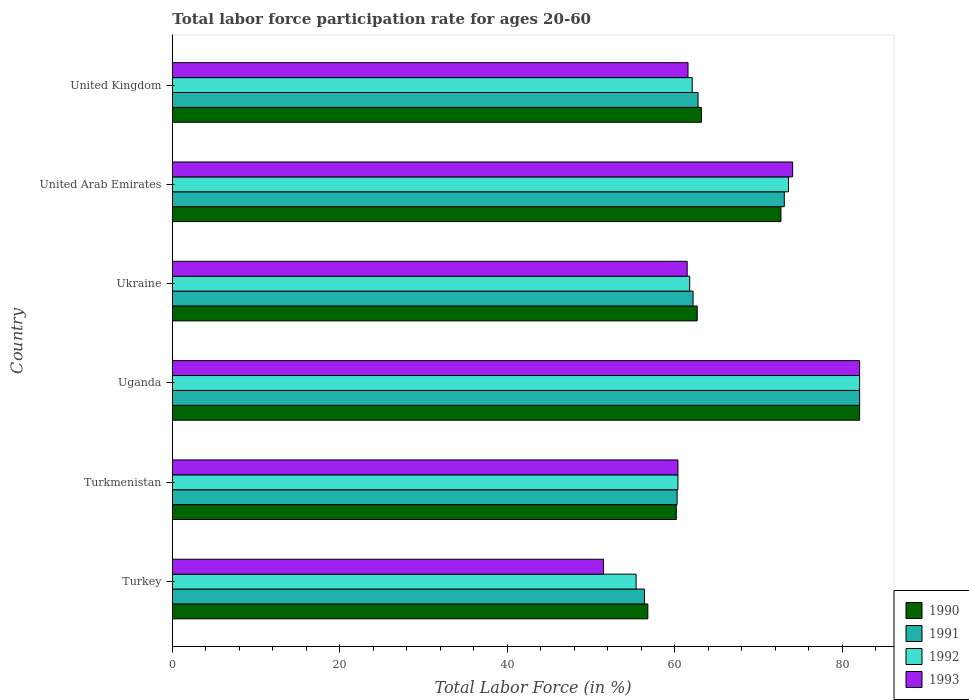How many groups of bars are there?
Give a very brief answer. 6. How many bars are there on the 6th tick from the top?
Keep it short and to the point. 4. How many bars are there on the 5th tick from the bottom?
Your response must be concise. 4. In how many cases, is the number of bars for a given country not equal to the number of legend labels?
Keep it short and to the point. 0. What is the labor force participation rate in 1992 in United Kingdom?
Ensure brevity in your answer.  62.1. Across all countries, what is the maximum labor force participation rate in 1990?
Ensure brevity in your answer.  82.1. Across all countries, what is the minimum labor force participation rate in 1992?
Make the answer very short. 55.4. In which country was the labor force participation rate in 1991 maximum?
Offer a very short reply. Uganda. In which country was the labor force participation rate in 1992 minimum?
Keep it short and to the point. Turkey. What is the total labor force participation rate in 1992 in the graph?
Offer a terse response. 395.4. What is the difference between the labor force participation rate in 1991 in Turkey and that in United Arab Emirates?
Offer a very short reply. -16.7. What is the difference between the labor force participation rate in 1992 in Turkmenistan and the labor force participation rate in 1990 in United Arab Emirates?
Ensure brevity in your answer.  -12.3. What is the average labor force participation rate in 1990 per country?
Provide a succinct answer. 66.28. What is the difference between the labor force participation rate in 1990 and labor force participation rate in 1991 in Turkmenistan?
Your answer should be compact. -0.1. In how many countries, is the labor force participation rate in 1991 greater than 60 %?
Ensure brevity in your answer.  5. What is the ratio of the labor force participation rate in 1991 in Turkmenistan to that in Uganda?
Provide a succinct answer. 0.73. Is the labor force participation rate in 1991 in United Arab Emirates less than that in United Kingdom?
Make the answer very short. No. Is the difference between the labor force participation rate in 1990 in Uganda and United Kingdom greater than the difference between the labor force participation rate in 1991 in Uganda and United Kingdom?
Your response must be concise. No. What is the difference between the highest and the lowest labor force participation rate in 1992?
Ensure brevity in your answer.  26.7. In how many countries, is the labor force participation rate in 1990 greater than the average labor force participation rate in 1990 taken over all countries?
Keep it short and to the point. 2. What does the 1st bar from the top in Ukraine represents?
Ensure brevity in your answer.  1993. Are all the bars in the graph horizontal?
Keep it short and to the point. Yes. How many countries are there in the graph?
Keep it short and to the point. 6. What is the difference between two consecutive major ticks on the X-axis?
Make the answer very short. 20. Are the values on the major ticks of X-axis written in scientific E-notation?
Give a very brief answer. No. Does the graph contain any zero values?
Your answer should be very brief. No. Does the graph contain grids?
Offer a very short reply. No. Where does the legend appear in the graph?
Offer a very short reply. Bottom right. How many legend labels are there?
Make the answer very short. 4. What is the title of the graph?
Your answer should be compact. Total labor force participation rate for ages 20-60. Does "1966" appear as one of the legend labels in the graph?
Provide a succinct answer. No. What is the label or title of the X-axis?
Provide a short and direct response. Total Labor Force (in %). What is the label or title of the Y-axis?
Provide a succinct answer. Country. What is the Total Labor Force (in %) in 1990 in Turkey?
Give a very brief answer. 56.8. What is the Total Labor Force (in %) of 1991 in Turkey?
Keep it short and to the point. 56.4. What is the Total Labor Force (in %) of 1992 in Turkey?
Offer a terse response. 55.4. What is the Total Labor Force (in %) in 1993 in Turkey?
Offer a very short reply. 51.5. What is the Total Labor Force (in %) in 1990 in Turkmenistan?
Ensure brevity in your answer.  60.2. What is the Total Labor Force (in %) of 1991 in Turkmenistan?
Your answer should be compact. 60.3. What is the Total Labor Force (in %) in 1992 in Turkmenistan?
Ensure brevity in your answer.  60.4. What is the Total Labor Force (in %) in 1993 in Turkmenistan?
Give a very brief answer. 60.4. What is the Total Labor Force (in %) of 1990 in Uganda?
Provide a succinct answer. 82.1. What is the Total Labor Force (in %) of 1991 in Uganda?
Provide a succinct answer. 82.1. What is the Total Labor Force (in %) in 1992 in Uganda?
Ensure brevity in your answer.  82.1. What is the Total Labor Force (in %) of 1993 in Uganda?
Provide a short and direct response. 82.1. What is the Total Labor Force (in %) in 1990 in Ukraine?
Your answer should be very brief. 62.7. What is the Total Labor Force (in %) in 1991 in Ukraine?
Your answer should be compact. 62.2. What is the Total Labor Force (in %) of 1992 in Ukraine?
Ensure brevity in your answer.  61.8. What is the Total Labor Force (in %) of 1993 in Ukraine?
Make the answer very short. 61.5. What is the Total Labor Force (in %) in 1990 in United Arab Emirates?
Make the answer very short. 72.7. What is the Total Labor Force (in %) of 1991 in United Arab Emirates?
Make the answer very short. 73.1. What is the Total Labor Force (in %) in 1992 in United Arab Emirates?
Give a very brief answer. 73.6. What is the Total Labor Force (in %) of 1993 in United Arab Emirates?
Keep it short and to the point. 74.1. What is the Total Labor Force (in %) in 1990 in United Kingdom?
Give a very brief answer. 63.2. What is the Total Labor Force (in %) in 1991 in United Kingdom?
Ensure brevity in your answer.  62.8. What is the Total Labor Force (in %) of 1992 in United Kingdom?
Keep it short and to the point. 62.1. What is the Total Labor Force (in %) of 1993 in United Kingdom?
Keep it short and to the point. 61.6. Across all countries, what is the maximum Total Labor Force (in %) in 1990?
Your response must be concise. 82.1. Across all countries, what is the maximum Total Labor Force (in %) in 1991?
Keep it short and to the point. 82.1. Across all countries, what is the maximum Total Labor Force (in %) in 1992?
Provide a short and direct response. 82.1. Across all countries, what is the maximum Total Labor Force (in %) in 1993?
Keep it short and to the point. 82.1. Across all countries, what is the minimum Total Labor Force (in %) in 1990?
Provide a succinct answer. 56.8. Across all countries, what is the minimum Total Labor Force (in %) in 1991?
Keep it short and to the point. 56.4. Across all countries, what is the minimum Total Labor Force (in %) of 1992?
Make the answer very short. 55.4. Across all countries, what is the minimum Total Labor Force (in %) in 1993?
Your answer should be compact. 51.5. What is the total Total Labor Force (in %) in 1990 in the graph?
Keep it short and to the point. 397.7. What is the total Total Labor Force (in %) in 1991 in the graph?
Ensure brevity in your answer.  396.9. What is the total Total Labor Force (in %) in 1992 in the graph?
Offer a terse response. 395.4. What is the total Total Labor Force (in %) in 1993 in the graph?
Provide a short and direct response. 391.2. What is the difference between the Total Labor Force (in %) in 1990 in Turkey and that in Turkmenistan?
Your answer should be compact. -3.4. What is the difference between the Total Labor Force (in %) of 1991 in Turkey and that in Turkmenistan?
Provide a succinct answer. -3.9. What is the difference between the Total Labor Force (in %) in 1992 in Turkey and that in Turkmenistan?
Provide a succinct answer. -5. What is the difference between the Total Labor Force (in %) of 1993 in Turkey and that in Turkmenistan?
Provide a succinct answer. -8.9. What is the difference between the Total Labor Force (in %) in 1990 in Turkey and that in Uganda?
Keep it short and to the point. -25.3. What is the difference between the Total Labor Force (in %) in 1991 in Turkey and that in Uganda?
Make the answer very short. -25.7. What is the difference between the Total Labor Force (in %) of 1992 in Turkey and that in Uganda?
Ensure brevity in your answer.  -26.7. What is the difference between the Total Labor Force (in %) of 1993 in Turkey and that in Uganda?
Offer a very short reply. -30.6. What is the difference between the Total Labor Force (in %) in 1991 in Turkey and that in Ukraine?
Give a very brief answer. -5.8. What is the difference between the Total Labor Force (in %) in 1992 in Turkey and that in Ukraine?
Keep it short and to the point. -6.4. What is the difference between the Total Labor Force (in %) in 1990 in Turkey and that in United Arab Emirates?
Give a very brief answer. -15.9. What is the difference between the Total Labor Force (in %) in 1991 in Turkey and that in United Arab Emirates?
Keep it short and to the point. -16.7. What is the difference between the Total Labor Force (in %) of 1992 in Turkey and that in United Arab Emirates?
Ensure brevity in your answer.  -18.2. What is the difference between the Total Labor Force (in %) of 1993 in Turkey and that in United Arab Emirates?
Provide a succinct answer. -22.6. What is the difference between the Total Labor Force (in %) of 1990 in Turkey and that in United Kingdom?
Keep it short and to the point. -6.4. What is the difference between the Total Labor Force (in %) of 1991 in Turkey and that in United Kingdom?
Provide a short and direct response. -6.4. What is the difference between the Total Labor Force (in %) in 1992 in Turkey and that in United Kingdom?
Offer a terse response. -6.7. What is the difference between the Total Labor Force (in %) in 1993 in Turkey and that in United Kingdom?
Give a very brief answer. -10.1. What is the difference between the Total Labor Force (in %) in 1990 in Turkmenistan and that in Uganda?
Offer a terse response. -21.9. What is the difference between the Total Labor Force (in %) in 1991 in Turkmenistan and that in Uganda?
Offer a very short reply. -21.8. What is the difference between the Total Labor Force (in %) of 1992 in Turkmenistan and that in Uganda?
Offer a terse response. -21.7. What is the difference between the Total Labor Force (in %) in 1993 in Turkmenistan and that in Uganda?
Offer a very short reply. -21.7. What is the difference between the Total Labor Force (in %) in 1990 in Turkmenistan and that in Ukraine?
Provide a short and direct response. -2.5. What is the difference between the Total Labor Force (in %) of 1992 in Turkmenistan and that in Ukraine?
Your response must be concise. -1.4. What is the difference between the Total Labor Force (in %) in 1993 in Turkmenistan and that in Ukraine?
Your response must be concise. -1.1. What is the difference between the Total Labor Force (in %) of 1991 in Turkmenistan and that in United Arab Emirates?
Your answer should be very brief. -12.8. What is the difference between the Total Labor Force (in %) of 1992 in Turkmenistan and that in United Arab Emirates?
Ensure brevity in your answer.  -13.2. What is the difference between the Total Labor Force (in %) in 1993 in Turkmenistan and that in United Arab Emirates?
Offer a terse response. -13.7. What is the difference between the Total Labor Force (in %) in 1992 in Turkmenistan and that in United Kingdom?
Your answer should be compact. -1.7. What is the difference between the Total Labor Force (in %) of 1990 in Uganda and that in Ukraine?
Your answer should be very brief. 19.4. What is the difference between the Total Labor Force (in %) of 1991 in Uganda and that in Ukraine?
Provide a succinct answer. 19.9. What is the difference between the Total Labor Force (in %) of 1992 in Uganda and that in Ukraine?
Ensure brevity in your answer.  20.3. What is the difference between the Total Labor Force (in %) of 1993 in Uganda and that in Ukraine?
Your answer should be compact. 20.6. What is the difference between the Total Labor Force (in %) of 1990 in Uganda and that in United Arab Emirates?
Provide a succinct answer. 9.4. What is the difference between the Total Labor Force (in %) of 1990 in Uganda and that in United Kingdom?
Make the answer very short. 18.9. What is the difference between the Total Labor Force (in %) in 1991 in Uganda and that in United Kingdom?
Keep it short and to the point. 19.3. What is the difference between the Total Labor Force (in %) in 1990 in Ukraine and that in United Arab Emirates?
Your answer should be very brief. -10. What is the difference between the Total Labor Force (in %) of 1993 in Ukraine and that in United Arab Emirates?
Offer a very short reply. -12.6. What is the difference between the Total Labor Force (in %) of 1990 in Ukraine and that in United Kingdom?
Make the answer very short. -0.5. What is the difference between the Total Labor Force (in %) in 1991 in Ukraine and that in United Kingdom?
Provide a succinct answer. -0.6. What is the difference between the Total Labor Force (in %) in 1990 in United Arab Emirates and that in United Kingdom?
Keep it short and to the point. 9.5. What is the difference between the Total Labor Force (in %) of 1991 in United Arab Emirates and that in United Kingdom?
Provide a short and direct response. 10.3. What is the difference between the Total Labor Force (in %) of 1993 in United Arab Emirates and that in United Kingdom?
Provide a short and direct response. 12.5. What is the difference between the Total Labor Force (in %) of 1990 in Turkey and the Total Labor Force (in %) of 1991 in Turkmenistan?
Your answer should be very brief. -3.5. What is the difference between the Total Labor Force (in %) of 1990 in Turkey and the Total Labor Force (in %) of 1992 in Turkmenistan?
Provide a short and direct response. -3.6. What is the difference between the Total Labor Force (in %) of 1990 in Turkey and the Total Labor Force (in %) of 1993 in Turkmenistan?
Keep it short and to the point. -3.6. What is the difference between the Total Labor Force (in %) in 1990 in Turkey and the Total Labor Force (in %) in 1991 in Uganda?
Your answer should be very brief. -25.3. What is the difference between the Total Labor Force (in %) in 1990 in Turkey and the Total Labor Force (in %) in 1992 in Uganda?
Offer a very short reply. -25.3. What is the difference between the Total Labor Force (in %) of 1990 in Turkey and the Total Labor Force (in %) of 1993 in Uganda?
Give a very brief answer. -25.3. What is the difference between the Total Labor Force (in %) in 1991 in Turkey and the Total Labor Force (in %) in 1992 in Uganda?
Offer a terse response. -25.7. What is the difference between the Total Labor Force (in %) in 1991 in Turkey and the Total Labor Force (in %) in 1993 in Uganda?
Your response must be concise. -25.7. What is the difference between the Total Labor Force (in %) of 1992 in Turkey and the Total Labor Force (in %) of 1993 in Uganda?
Make the answer very short. -26.7. What is the difference between the Total Labor Force (in %) of 1991 in Turkey and the Total Labor Force (in %) of 1992 in Ukraine?
Keep it short and to the point. -5.4. What is the difference between the Total Labor Force (in %) in 1991 in Turkey and the Total Labor Force (in %) in 1993 in Ukraine?
Ensure brevity in your answer.  -5.1. What is the difference between the Total Labor Force (in %) in 1990 in Turkey and the Total Labor Force (in %) in 1991 in United Arab Emirates?
Your answer should be very brief. -16.3. What is the difference between the Total Labor Force (in %) in 1990 in Turkey and the Total Labor Force (in %) in 1992 in United Arab Emirates?
Offer a terse response. -16.8. What is the difference between the Total Labor Force (in %) in 1990 in Turkey and the Total Labor Force (in %) in 1993 in United Arab Emirates?
Ensure brevity in your answer.  -17.3. What is the difference between the Total Labor Force (in %) in 1991 in Turkey and the Total Labor Force (in %) in 1992 in United Arab Emirates?
Keep it short and to the point. -17.2. What is the difference between the Total Labor Force (in %) in 1991 in Turkey and the Total Labor Force (in %) in 1993 in United Arab Emirates?
Keep it short and to the point. -17.7. What is the difference between the Total Labor Force (in %) of 1992 in Turkey and the Total Labor Force (in %) of 1993 in United Arab Emirates?
Provide a short and direct response. -18.7. What is the difference between the Total Labor Force (in %) of 1990 in Turkey and the Total Labor Force (in %) of 1993 in United Kingdom?
Your response must be concise. -4.8. What is the difference between the Total Labor Force (in %) of 1991 in Turkey and the Total Labor Force (in %) of 1992 in United Kingdom?
Your answer should be compact. -5.7. What is the difference between the Total Labor Force (in %) of 1992 in Turkey and the Total Labor Force (in %) of 1993 in United Kingdom?
Provide a short and direct response. -6.2. What is the difference between the Total Labor Force (in %) of 1990 in Turkmenistan and the Total Labor Force (in %) of 1991 in Uganda?
Give a very brief answer. -21.9. What is the difference between the Total Labor Force (in %) of 1990 in Turkmenistan and the Total Labor Force (in %) of 1992 in Uganda?
Your answer should be very brief. -21.9. What is the difference between the Total Labor Force (in %) in 1990 in Turkmenistan and the Total Labor Force (in %) in 1993 in Uganda?
Provide a short and direct response. -21.9. What is the difference between the Total Labor Force (in %) in 1991 in Turkmenistan and the Total Labor Force (in %) in 1992 in Uganda?
Offer a terse response. -21.8. What is the difference between the Total Labor Force (in %) of 1991 in Turkmenistan and the Total Labor Force (in %) of 1993 in Uganda?
Ensure brevity in your answer.  -21.8. What is the difference between the Total Labor Force (in %) of 1992 in Turkmenistan and the Total Labor Force (in %) of 1993 in Uganda?
Your answer should be very brief. -21.7. What is the difference between the Total Labor Force (in %) of 1990 in Turkmenistan and the Total Labor Force (in %) of 1991 in Ukraine?
Provide a short and direct response. -2. What is the difference between the Total Labor Force (in %) of 1990 in Turkmenistan and the Total Labor Force (in %) of 1992 in Ukraine?
Offer a terse response. -1.6. What is the difference between the Total Labor Force (in %) of 1990 in Turkmenistan and the Total Labor Force (in %) of 1993 in Ukraine?
Your answer should be compact. -1.3. What is the difference between the Total Labor Force (in %) in 1991 in Turkmenistan and the Total Labor Force (in %) in 1992 in Ukraine?
Ensure brevity in your answer.  -1.5. What is the difference between the Total Labor Force (in %) of 1991 in Turkmenistan and the Total Labor Force (in %) of 1993 in Ukraine?
Provide a succinct answer. -1.2. What is the difference between the Total Labor Force (in %) in 1992 in Turkmenistan and the Total Labor Force (in %) in 1993 in Ukraine?
Offer a very short reply. -1.1. What is the difference between the Total Labor Force (in %) of 1990 in Turkmenistan and the Total Labor Force (in %) of 1992 in United Arab Emirates?
Ensure brevity in your answer.  -13.4. What is the difference between the Total Labor Force (in %) in 1991 in Turkmenistan and the Total Labor Force (in %) in 1992 in United Arab Emirates?
Give a very brief answer. -13.3. What is the difference between the Total Labor Force (in %) in 1991 in Turkmenistan and the Total Labor Force (in %) in 1993 in United Arab Emirates?
Your answer should be compact. -13.8. What is the difference between the Total Labor Force (in %) in 1992 in Turkmenistan and the Total Labor Force (in %) in 1993 in United Arab Emirates?
Provide a succinct answer. -13.7. What is the difference between the Total Labor Force (in %) in 1991 in Turkmenistan and the Total Labor Force (in %) in 1993 in United Kingdom?
Your answer should be very brief. -1.3. What is the difference between the Total Labor Force (in %) in 1992 in Turkmenistan and the Total Labor Force (in %) in 1993 in United Kingdom?
Offer a very short reply. -1.2. What is the difference between the Total Labor Force (in %) in 1990 in Uganda and the Total Labor Force (in %) in 1992 in Ukraine?
Offer a terse response. 20.3. What is the difference between the Total Labor Force (in %) in 1990 in Uganda and the Total Labor Force (in %) in 1993 in Ukraine?
Your response must be concise. 20.6. What is the difference between the Total Labor Force (in %) of 1991 in Uganda and the Total Labor Force (in %) of 1992 in Ukraine?
Provide a short and direct response. 20.3. What is the difference between the Total Labor Force (in %) of 1991 in Uganda and the Total Labor Force (in %) of 1993 in Ukraine?
Give a very brief answer. 20.6. What is the difference between the Total Labor Force (in %) of 1992 in Uganda and the Total Labor Force (in %) of 1993 in Ukraine?
Your answer should be very brief. 20.6. What is the difference between the Total Labor Force (in %) in 1991 in Uganda and the Total Labor Force (in %) in 1992 in United Arab Emirates?
Your response must be concise. 8.5. What is the difference between the Total Labor Force (in %) of 1991 in Uganda and the Total Labor Force (in %) of 1993 in United Arab Emirates?
Your answer should be very brief. 8. What is the difference between the Total Labor Force (in %) in 1990 in Uganda and the Total Labor Force (in %) in 1991 in United Kingdom?
Your answer should be compact. 19.3. What is the difference between the Total Labor Force (in %) of 1990 in Uganda and the Total Labor Force (in %) of 1993 in United Kingdom?
Your answer should be compact. 20.5. What is the difference between the Total Labor Force (in %) in 1991 in Uganda and the Total Labor Force (in %) in 1992 in United Kingdom?
Your response must be concise. 20. What is the difference between the Total Labor Force (in %) in 1992 in Uganda and the Total Labor Force (in %) in 1993 in United Kingdom?
Offer a terse response. 20.5. What is the difference between the Total Labor Force (in %) of 1990 in Ukraine and the Total Labor Force (in %) of 1992 in United Arab Emirates?
Your response must be concise. -10.9. What is the difference between the Total Labor Force (in %) in 1992 in Ukraine and the Total Labor Force (in %) in 1993 in United Arab Emirates?
Offer a terse response. -12.3. What is the difference between the Total Labor Force (in %) of 1990 in Ukraine and the Total Labor Force (in %) of 1992 in United Kingdom?
Ensure brevity in your answer.  0.6. What is the difference between the Total Labor Force (in %) of 1990 in Ukraine and the Total Labor Force (in %) of 1993 in United Kingdom?
Provide a succinct answer. 1.1. What is the difference between the Total Labor Force (in %) of 1991 in Ukraine and the Total Labor Force (in %) of 1992 in United Kingdom?
Keep it short and to the point. 0.1. What is the difference between the Total Labor Force (in %) of 1990 in United Arab Emirates and the Total Labor Force (in %) of 1991 in United Kingdom?
Keep it short and to the point. 9.9. What is the difference between the Total Labor Force (in %) in 1991 in United Arab Emirates and the Total Labor Force (in %) in 1992 in United Kingdom?
Give a very brief answer. 11. What is the difference between the Total Labor Force (in %) of 1991 in United Arab Emirates and the Total Labor Force (in %) of 1993 in United Kingdom?
Offer a very short reply. 11.5. What is the average Total Labor Force (in %) in 1990 per country?
Ensure brevity in your answer.  66.28. What is the average Total Labor Force (in %) in 1991 per country?
Keep it short and to the point. 66.15. What is the average Total Labor Force (in %) of 1992 per country?
Give a very brief answer. 65.9. What is the average Total Labor Force (in %) of 1993 per country?
Your answer should be compact. 65.2. What is the difference between the Total Labor Force (in %) in 1990 and Total Labor Force (in %) in 1991 in Turkey?
Keep it short and to the point. 0.4. What is the difference between the Total Labor Force (in %) of 1991 and Total Labor Force (in %) of 1992 in Turkey?
Keep it short and to the point. 1. What is the difference between the Total Labor Force (in %) in 1992 and Total Labor Force (in %) in 1993 in Turkey?
Your response must be concise. 3.9. What is the difference between the Total Labor Force (in %) of 1990 and Total Labor Force (in %) of 1992 in Turkmenistan?
Your answer should be compact. -0.2. What is the difference between the Total Labor Force (in %) of 1992 and Total Labor Force (in %) of 1993 in Turkmenistan?
Make the answer very short. 0. What is the difference between the Total Labor Force (in %) in 1990 and Total Labor Force (in %) in 1992 in Uganda?
Your response must be concise. 0. What is the difference between the Total Labor Force (in %) in 1990 and Total Labor Force (in %) in 1992 in Ukraine?
Provide a succinct answer. 0.9. What is the difference between the Total Labor Force (in %) in 1990 and Total Labor Force (in %) in 1993 in Ukraine?
Keep it short and to the point. 1.2. What is the difference between the Total Labor Force (in %) in 1990 and Total Labor Force (in %) in 1992 in United Arab Emirates?
Your response must be concise. -0.9. What is the difference between the Total Labor Force (in %) of 1990 and Total Labor Force (in %) of 1993 in United Arab Emirates?
Offer a terse response. -1.4. What is the difference between the Total Labor Force (in %) of 1991 and Total Labor Force (in %) of 1992 in United Arab Emirates?
Your answer should be compact. -0.5. What is the difference between the Total Labor Force (in %) in 1990 and Total Labor Force (in %) in 1992 in United Kingdom?
Your response must be concise. 1.1. What is the difference between the Total Labor Force (in %) in 1990 and Total Labor Force (in %) in 1993 in United Kingdom?
Your answer should be compact. 1.6. What is the difference between the Total Labor Force (in %) of 1991 and Total Labor Force (in %) of 1992 in United Kingdom?
Your response must be concise. 0.7. What is the difference between the Total Labor Force (in %) in 1991 and Total Labor Force (in %) in 1993 in United Kingdom?
Your answer should be compact. 1.2. What is the difference between the Total Labor Force (in %) of 1992 and Total Labor Force (in %) of 1993 in United Kingdom?
Keep it short and to the point. 0.5. What is the ratio of the Total Labor Force (in %) in 1990 in Turkey to that in Turkmenistan?
Provide a succinct answer. 0.94. What is the ratio of the Total Labor Force (in %) of 1991 in Turkey to that in Turkmenistan?
Keep it short and to the point. 0.94. What is the ratio of the Total Labor Force (in %) of 1992 in Turkey to that in Turkmenistan?
Make the answer very short. 0.92. What is the ratio of the Total Labor Force (in %) of 1993 in Turkey to that in Turkmenistan?
Provide a short and direct response. 0.85. What is the ratio of the Total Labor Force (in %) of 1990 in Turkey to that in Uganda?
Ensure brevity in your answer.  0.69. What is the ratio of the Total Labor Force (in %) in 1991 in Turkey to that in Uganda?
Provide a succinct answer. 0.69. What is the ratio of the Total Labor Force (in %) of 1992 in Turkey to that in Uganda?
Give a very brief answer. 0.67. What is the ratio of the Total Labor Force (in %) of 1993 in Turkey to that in Uganda?
Offer a terse response. 0.63. What is the ratio of the Total Labor Force (in %) of 1990 in Turkey to that in Ukraine?
Provide a succinct answer. 0.91. What is the ratio of the Total Labor Force (in %) of 1991 in Turkey to that in Ukraine?
Your response must be concise. 0.91. What is the ratio of the Total Labor Force (in %) of 1992 in Turkey to that in Ukraine?
Give a very brief answer. 0.9. What is the ratio of the Total Labor Force (in %) of 1993 in Turkey to that in Ukraine?
Your answer should be very brief. 0.84. What is the ratio of the Total Labor Force (in %) of 1990 in Turkey to that in United Arab Emirates?
Provide a succinct answer. 0.78. What is the ratio of the Total Labor Force (in %) of 1991 in Turkey to that in United Arab Emirates?
Provide a short and direct response. 0.77. What is the ratio of the Total Labor Force (in %) in 1992 in Turkey to that in United Arab Emirates?
Keep it short and to the point. 0.75. What is the ratio of the Total Labor Force (in %) in 1993 in Turkey to that in United Arab Emirates?
Keep it short and to the point. 0.69. What is the ratio of the Total Labor Force (in %) in 1990 in Turkey to that in United Kingdom?
Make the answer very short. 0.9. What is the ratio of the Total Labor Force (in %) in 1991 in Turkey to that in United Kingdom?
Your response must be concise. 0.9. What is the ratio of the Total Labor Force (in %) in 1992 in Turkey to that in United Kingdom?
Keep it short and to the point. 0.89. What is the ratio of the Total Labor Force (in %) in 1993 in Turkey to that in United Kingdom?
Give a very brief answer. 0.84. What is the ratio of the Total Labor Force (in %) in 1990 in Turkmenistan to that in Uganda?
Make the answer very short. 0.73. What is the ratio of the Total Labor Force (in %) in 1991 in Turkmenistan to that in Uganda?
Give a very brief answer. 0.73. What is the ratio of the Total Labor Force (in %) in 1992 in Turkmenistan to that in Uganda?
Provide a short and direct response. 0.74. What is the ratio of the Total Labor Force (in %) in 1993 in Turkmenistan to that in Uganda?
Make the answer very short. 0.74. What is the ratio of the Total Labor Force (in %) in 1990 in Turkmenistan to that in Ukraine?
Your answer should be very brief. 0.96. What is the ratio of the Total Labor Force (in %) of 1991 in Turkmenistan to that in Ukraine?
Offer a very short reply. 0.97. What is the ratio of the Total Labor Force (in %) of 1992 in Turkmenistan to that in Ukraine?
Make the answer very short. 0.98. What is the ratio of the Total Labor Force (in %) in 1993 in Turkmenistan to that in Ukraine?
Make the answer very short. 0.98. What is the ratio of the Total Labor Force (in %) of 1990 in Turkmenistan to that in United Arab Emirates?
Provide a short and direct response. 0.83. What is the ratio of the Total Labor Force (in %) of 1991 in Turkmenistan to that in United Arab Emirates?
Ensure brevity in your answer.  0.82. What is the ratio of the Total Labor Force (in %) of 1992 in Turkmenistan to that in United Arab Emirates?
Your answer should be very brief. 0.82. What is the ratio of the Total Labor Force (in %) of 1993 in Turkmenistan to that in United Arab Emirates?
Offer a terse response. 0.82. What is the ratio of the Total Labor Force (in %) of 1990 in Turkmenistan to that in United Kingdom?
Offer a terse response. 0.95. What is the ratio of the Total Labor Force (in %) of 1991 in Turkmenistan to that in United Kingdom?
Your answer should be compact. 0.96. What is the ratio of the Total Labor Force (in %) of 1992 in Turkmenistan to that in United Kingdom?
Keep it short and to the point. 0.97. What is the ratio of the Total Labor Force (in %) in 1993 in Turkmenistan to that in United Kingdom?
Keep it short and to the point. 0.98. What is the ratio of the Total Labor Force (in %) in 1990 in Uganda to that in Ukraine?
Keep it short and to the point. 1.31. What is the ratio of the Total Labor Force (in %) in 1991 in Uganda to that in Ukraine?
Offer a terse response. 1.32. What is the ratio of the Total Labor Force (in %) in 1992 in Uganda to that in Ukraine?
Make the answer very short. 1.33. What is the ratio of the Total Labor Force (in %) in 1993 in Uganda to that in Ukraine?
Your answer should be very brief. 1.33. What is the ratio of the Total Labor Force (in %) in 1990 in Uganda to that in United Arab Emirates?
Give a very brief answer. 1.13. What is the ratio of the Total Labor Force (in %) in 1991 in Uganda to that in United Arab Emirates?
Offer a very short reply. 1.12. What is the ratio of the Total Labor Force (in %) of 1992 in Uganda to that in United Arab Emirates?
Offer a very short reply. 1.12. What is the ratio of the Total Labor Force (in %) in 1993 in Uganda to that in United Arab Emirates?
Provide a short and direct response. 1.11. What is the ratio of the Total Labor Force (in %) of 1990 in Uganda to that in United Kingdom?
Offer a very short reply. 1.3. What is the ratio of the Total Labor Force (in %) in 1991 in Uganda to that in United Kingdom?
Your response must be concise. 1.31. What is the ratio of the Total Labor Force (in %) of 1992 in Uganda to that in United Kingdom?
Your response must be concise. 1.32. What is the ratio of the Total Labor Force (in %) of 1993 in Uganda to that in United Kingdom?
Give a very brief answer. 1.33. What is the ratio of the Total Labor Force (in %) in 1990 in Ukraine to that in United Arab Emirates?
Your answer should be very brief. 0.86. What is the ratio of the Total Labor Force (in %) of 1991 in Ukraine to that in United Arab Emirates?
Make the answer very short. 0.85. What is the ratio of the Total Labor Force (in %) of 1992 in Ukraine to that in United Arab Emirates?
Provide a short and direct response. 0.84. What is the ratio of the Total Labor Force (in %) of 1993 in Ukraine to that in United Arab Emirates?
Provide a short and direct response. 0.83. What is the ratio of the Total Labor Force (in %) of 1991 in Ukraine to that in United Kingdom?
Provide a short and direct response. 0.99. What is the ratio of the Total Labor Force (in %) in 1993 in Ukraine to that in United Kingdom?
Your response must be concise. 1. What is the ratio of the Total Labor Force (in %) of 1990 in United Arab Emirates to that in United Kingdom?
Your answer should be compact. 1.15. What is the ratio of the Total Labor Force (in %) of 1991 in United Arab Emirates to that in United Kingdom?
Provide a succinct answer. 1.16. What is the ratio of the Total Labor Force (in %) of 1992 in United Arab Emirates to that in United Kingdom?
Give a very brief answer. 1.19. What is the ratio of the Total Labor Force (in %) of 1993 in United Arab Emirates to that in United Kingdom?
Offer a very short reply. 1.2. What is the difference between the highest and the second highest Total Labor Force (in %) in 1990?
Ensure brevity in your answer.  9.4. What is the difference between the highest and the second highest Total Labor Force (in %) of 1991?
Give a very brief answer. 9. What is the difference between the highest and the second highest Total Labor Force (in %) of 1992?
Your answer should be compact. 8.5. What is the difference between the highest and the lowest Total Labor Force (in %) in 1990?
Keep it short and to the point. 25.3. What is the difference between the highest and the lowest Total Labor Force (in %) in 1991?
Ensure brevity in your answer.  25.7. What is the difference between the highest and the lowest Total Labor Force (in %) in 1992?
Provide a short and direct response. 26.7. What is the difference between the highest and the lowest Total Labor Force (in %) in 1993?
Ensure brevity in your answer.  30.6. 